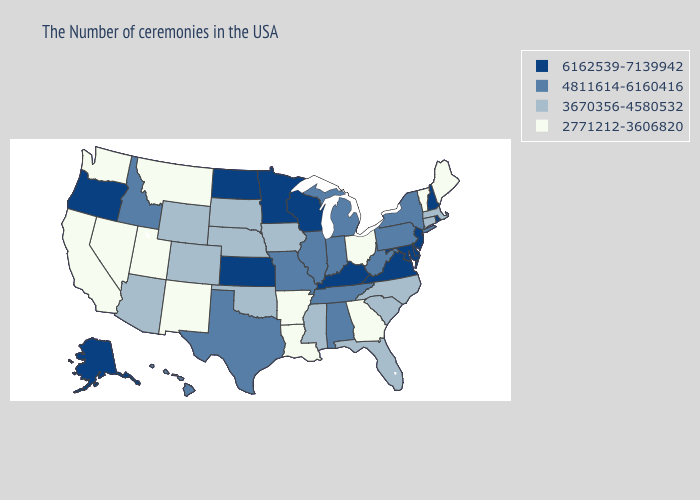Does Wyoming have a higher value than Kansas?
Concise answer only. No. Does West Virginia have the lowest value in the USA?
Keep it brief. No. Does the first symbol in the legend represent the smallest category?
Quick response, please. No. What is the lowest value in the South?
Concise answer only. 2771212-3606820. Name the states that have a value in the range 2771212-3606820?
Concise answer only. Maine, Vermont, Ohio, Georgia, Louisiana, Arkansas, New Mexico, Utah, Montana, Nevada, California, Washington. What is the lowest value in the USA?
Write a very short answer. 2771212-3606820. Name the states that have a value in the range 2771212-3606820?
Be succinct. Maine, Vermont, Ohio, Georgia, Louisiana, Arkansas, New Mexico, Utah, Montana, Nevada, California, Washington. Does Oklahoma have the same value as Montana?
Write a very short answer. No. Name the states that have a value in the range 3670356-4580532?
Quick response, please. Massachusetts, Connecticut, North Carolina, South Carolina, Florida, Mississippi, Iowa, Nebraska, Oklahoma, South Dakota, Wyoming, Colorado, Arizona. Does the first symbol in the legend represent the smallest category?
Keep it brief. No. Does Hawaii have the highest value in the USA?
Concise answer only. No. Does the first symbol in the legend represent the smallest category?
Concise answer only. No. What is the lowest value in states that border Michigan?
Quick response, please. 2771212-3606820. How many symbols are there in the legend?
Answer briefly. 4. 